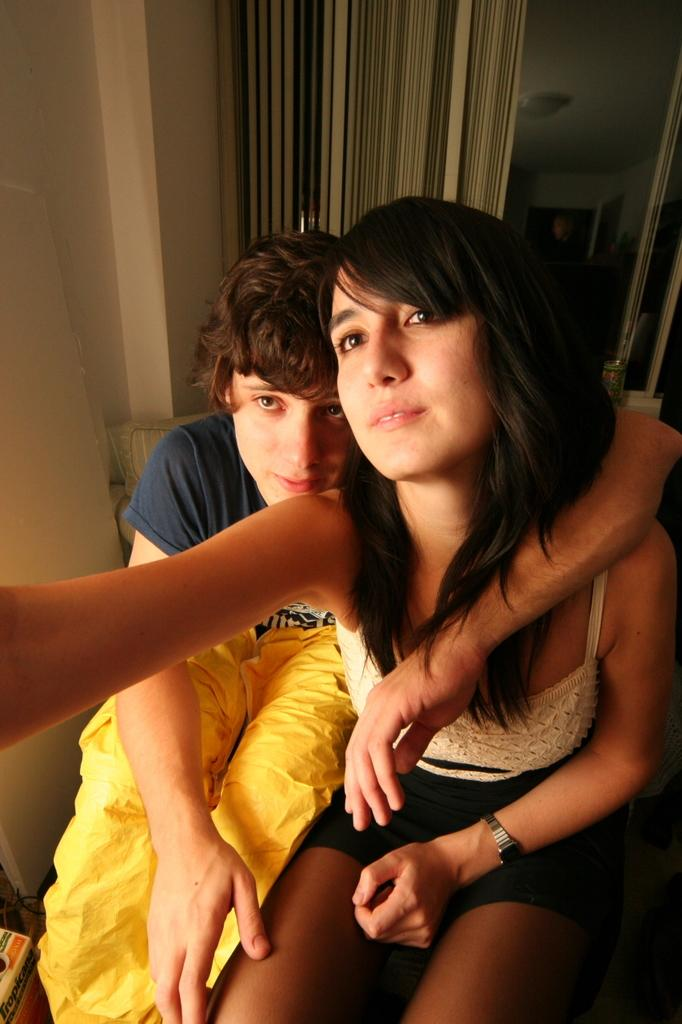Who are the two people in the image? There is a girl and a boy in the image. Where are the girl and boy located in the image? The girl and boy are in the middle of the image. What can be seen in the background of the image? There is a glass wall and a window curtain in the background of the image. What type of jewel is the girl wearing in the image? There is no mention of a jewel in the image, so it cannot be determined if the girl is wearing one. 